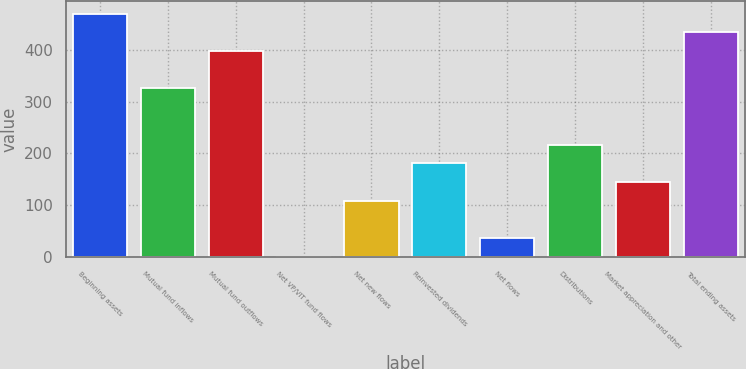Convert chart to OTSL. <chart><loc_0><loc_0><loc_500><loc_500><bar_chart><fcel>Beginning assets<fcel>Mutual fund inflows<fcel>Mutual fund outflows<fcel>Net VP/VIT fund flows<fcel>Net new flows<fcel>Reinvested dividends<fcel>Net flows<fcel>Distributions<fcel>Market appreciation and other<fcel>Total ending assets<nl><fcel>469.29<fcel>325.17<fcel>397.23<fcel>0.9<fcel>108.99<fcel>181.05<fcel>36.93<fcel>217.08<fcel>145.02<fcel>433.26<nl></chart> 